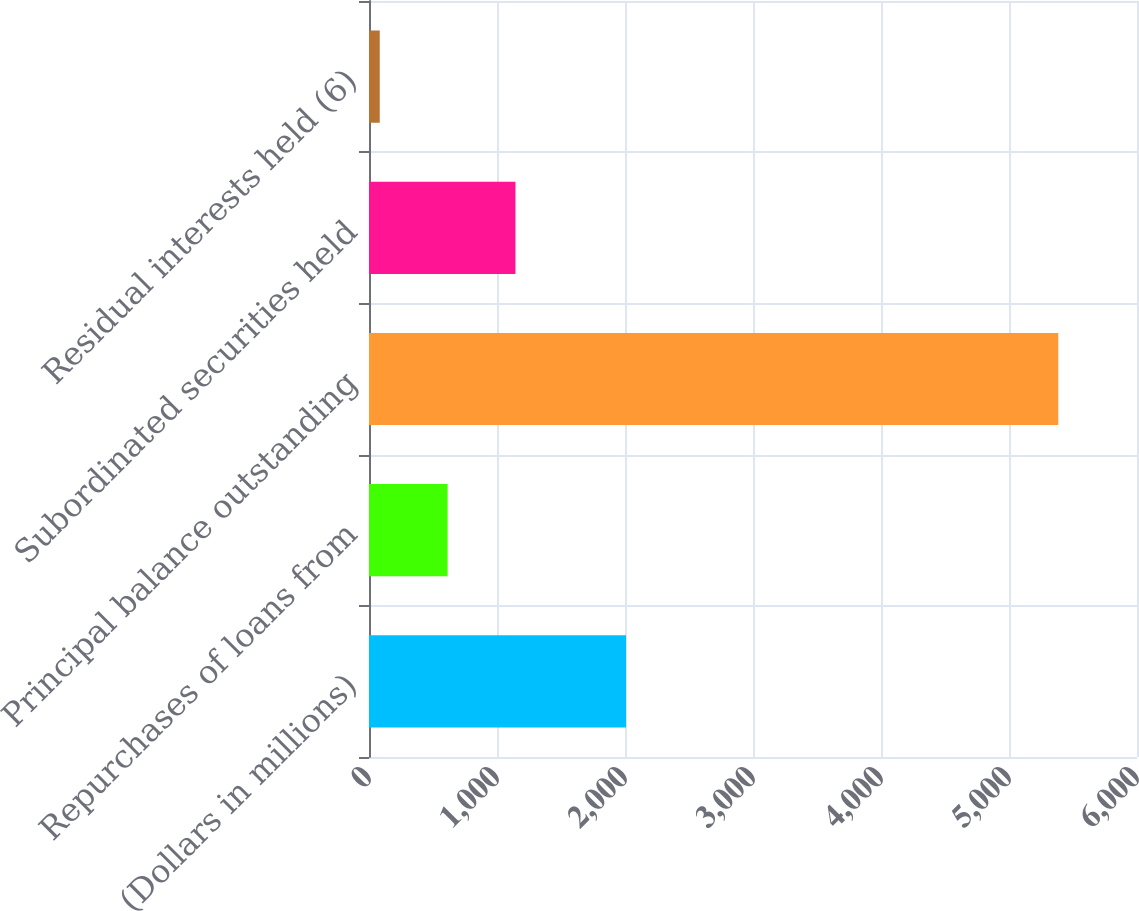<chart> <loc_0><loc_0><loc_500><loc_500><bar_chart><fcel>(Dollars in millions)<fcel>Repurchases of loans from<fcel>Principal balance outstanding<fcel>Subordinated securities held<fcel>Residual interests held (6)<nl><fcel>2008<fcel>614.1<fcel>5385<fcel>1144.2<fcel>84<nl></chart> 